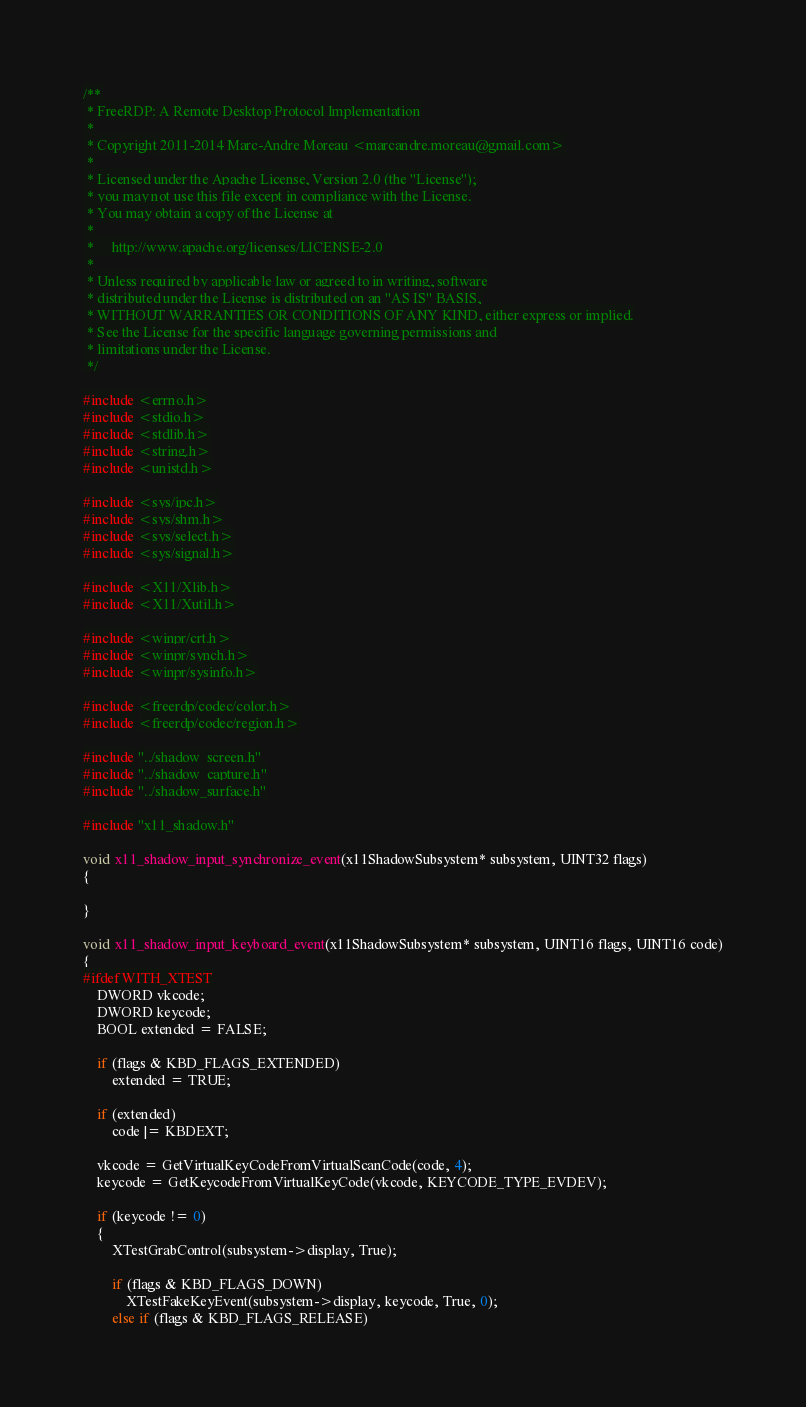<code> <loc_0><loc_0><loc_500><loc_500><_C_>/**
 * FreeRDP: A Remote Desktop Protocol Implementation
 *
 * Copyright 2011-2014 Marc-Andre Moreau <marcandre.moreau@gmail.com>
 *
 * Licensed under the Apache License, Version 2.0 (the "License");
 * you may not use this file except in compliance with the License.
 * You may obtain a copy of the License at
 *
 *     http://www.apache.org/licenses/LICENSE-2.0
 *
 * Unless required by applicable law or agreed to in writing, software
 * distributed under the License is distributed on an "AS IS" BASIS,
 * WITHOUT WARRANTIES OR CONDITIONS OF ANY KIND, either express or implied.
 * See the License for the specific language governing permissions and
 * limitations under the License.
 */

#include <errno.h>
#include <stdio.h>
#include <stdlib.h>
#include <string.h>
#include <unistd.h>

#include <sys/ipc.h>
#include <sys/shm.h>
#include <sys/select.h>
#include <sys/signal.h>

#include <X11/Xlib.h>
#include <X11/Xutil.h>

#include <winpr/crt.h>
#include <winpr/synch.h>
#include <winpr/sysinfo.h>

#include <freerdp/codec/color.h>
#include <freerdp/codec/region.h>

#include "../shadow_screen.h"
#include "../shadow_capture.h"
#include "../shadow_surface.h"

#include "x11_shadow.h"

void x11_shadow_input_synchronize_event(x11ShadowSubsystem* subsystem, UINT32 flags)
{

}

void x11_shadow_input_keyboard_event(x11ShadowSubsystem* subsystem, UINT16 flags, UINT16 code)
{
#ifdef WITH_XTEST
	DWORD vkcode;
	DWORD keycode;
	BOOL extended = FALSE;

	if (flags & KBD_FLAGS_EXTENDED)
		extended = TRUE;

	if (extended)
		code |= KBDEXT;

	vkcode = GetVirtualKeyCodeFromVirtualScanCode(code, 4);
	keycode = GetKeycodeFromVirtualKeyCode(vkcode, KEYCODE_TYPE_EVDEV);

	if (keycode != 0)
	{
		XTestGrabControl(subsystem->display, True);

		if (flags & KBD_FLAGS_DOWN)
			XTestFakeKeyEvent(subsystem->display, keycode, True, 0);
		else if (flags & KBD_FLAGS_RELEASE)</code> 